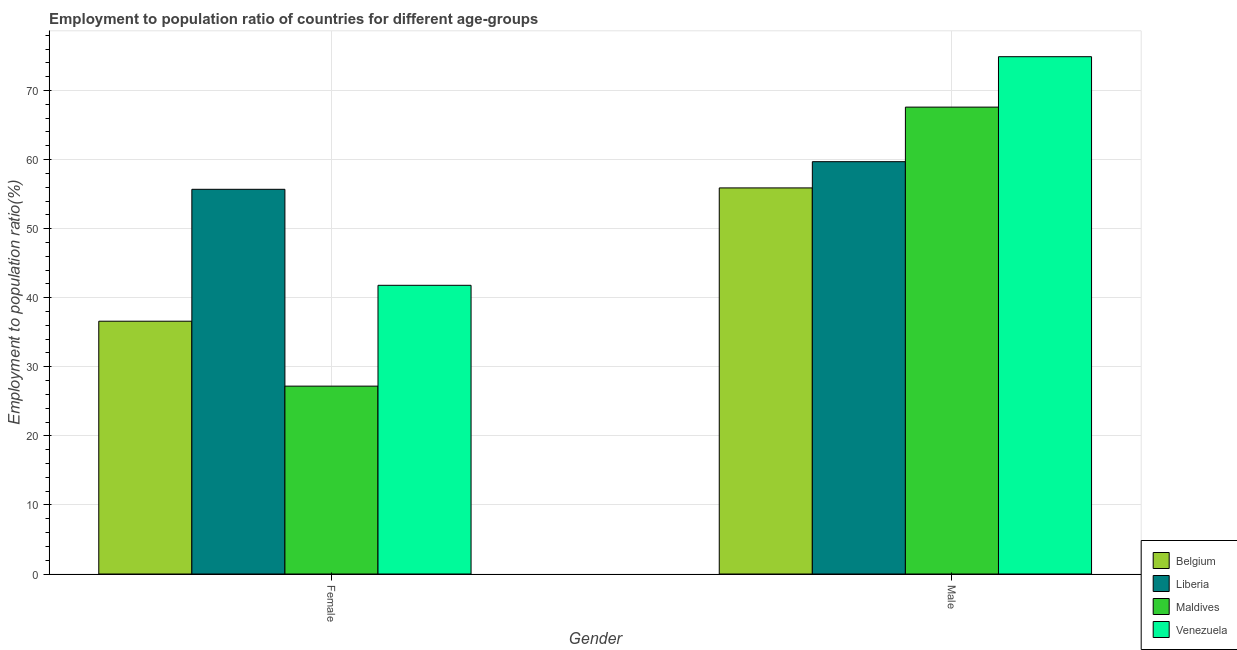How many different coloured bars are there?
Ensure brevity in your answer.  4. How many groups of bars are there?
Offer a terse response. 2. Are the number of bars per tick equal to the number of legend labels?
Provide a succinct answer. Yes. How many bars are there on the 2nd tick from the left?
Keep it short and to the point. 4. What is the label of the 2nd group of bars from the left?
Give a very brief answer. Male. What is the employment to population ratio(female) in Liberia?
Your answer should be very brief. 55.7. Across all countries, what is the maximum employment to population ratio(male)?
Offer a terse response. 74.9. Across all countries, what is the minimum employment to population ratio(male)?
Give a very brief answer. 55.9. In which country was the employment to population ratio(male) maximum?
Offer a very short reply. Venezuela. In which country was the employment to population ratio(female) minimum?
Offer a very short reply. Maldives. What is the total employment to population ratio(female) in the graph?
Provide a short and direct response. 161.3. What is the difference between the employment to population ratio(female) in Liberia and that in Belgium?
Keep it short and to the point. 19.1. What is the difference between the employment to population ratio(male) in Maldives and the employment to population ratio(female) in Liberia?
Make the answer very short. 11.9. What is the average employment to population ratio(female) per country?
Ensure brevity in your answer.  40.32. What is the difference between the employment to population ratio(female) and employment to population ratio(male) in Maldives?
Provide a short and direct response. -40.4. In how many countries, is the employment to population ratio(male) greater than 20 %?
Give a very brief answer. 4. What is the ratio of the employment to population ratio(male) in Liberia to that in Belgium?
Your response must be concise. 1.07. What does the 1st bar from the left in Female represents?
Your answer should be compact. Belgium. What does the 2nd bar from the right in Male represents?
Give a very brief answer. Maldives. How many countries are there in the graph?
Your answer should be compact. 4. What is the difference between two consecutive major ticks on the Y-axis?
Your response must be concise. 10. Are the values on the major ticks of Y-axis written in scientific E-notation?
Offer a terse response. No. Does the graph contain grids?
Offer a very short reply. Yes. How many legend labels are there?
Provide a succinct answer. 4. How are the legend labels stacked?
Keep it short and to the point. Vertical. What is the title of the graph?
Provide a succinct answer. Employment to population ratio of countries for different age-groups. What is the label or title of the X-axis?
Provide a short and direct response. Gender. What is the Employment to population ratio(%) in Belgium in Female?
Your response must be concise. 36.6. What is the Employment to population ratio(%) of Liberia in Female?
Keep it short and to the point. 55.7. What is the Employment to population ratio(%) of Maldives in Female?
Provide a succinct answer. 27.2. What is the Employment to population ratio(%) of Venezuela in Female?
Keep it short and to the point. 41.8. What is the Employment to population ratio(%) of Belgium in Male?
Offer a very short reply. 55.9. What is the Employment to population ratio(%) in Liberia in Male?
Your response must be concise. 59.7. What is the Employment to population ratio(%) of Maldives in Male?
Offer a terse response. 67.6. What is the Employment to population ratio(%) in Venezuela in Male?
Give a very brief answer. 74.9. Across all Gender, what is the maximum Employment to population ratio(%) of Belgium?
Give a very brief answer. 55.9. Across all Gender, what is the maximum Employment to population ratio(%) in Liberia?
Your answer should be very brief. 59.7. Across all Gender, what is the maximum Employment to population ratio(%) in Maldives?
Ensure brevity in your answer.  67.6. Across all Gender, what is the maximum Employment to population ratio(%) in Venezuela?
Provide a short and direct response. 74.9. Across all Gender, what is the minimum Employment to population ratio(%) in Belgium?
Offer a terse response. 36.6. Across all Gender, what is the minimum Employment to population ratio(%) of Liberia?
Offer a very short reply. 55.7. Across all Gender, what is the minimum Employment to population ratio(%) of Maldives?
Provide a succinct answer. 27.2. Across all Gender, what is the minimum Employment to population ratio(%) of Venezuela?
Your answer should be very brief. 41.8. What is the total Employment to population ratio(%) in Belgium in the graph?
Give a very brief answer. 92.5. What is the total Employment to population ratio(%) of Liberia in the graph?
Give a very brief answer. 115.4. What is the total Employment to population ratio(%) of Maldives in the graph?
Keep it short and to the point. 94.8. What is the total Employment to population ratio(%) of Venezuela in the graph?
Offer a terse response. 116.7. What is the difference between the Employment to population ratio(%) in Belgium in Female and that in Male?
Your response must be concise. -19.3. What is the difference between the Employment to population ratio(%) in Liberia in Female and that in Male?
Your answer should be compact. -4. What is the difference between the Employment to population ratio(%) of Maldives in Female and that in Male?
Offer a terse response. -40.4. What is the difference between the Employment to population ratio(%) of Venezuela in Female and that in Male?
Keep it short and to the point. -33.1. What is the difference between the Employment to population ratio(%) in Belgium in Female and the Employment to population ratio(%) in Liberia in Male?
Your response must be concise. -23.1. What is the difference between the Employment to population ratio(%) in Belgium in Female and the Employment to population ratio(%) in Maldives in Male?
Give a very brief answer. -31. What is the difference between the Employment to population ratio(%) in Belgium in Female and the Employment to population ratio(%) in Venezuela in Male?
Keep it short and to the point. -38.3. What is the difference between the Employment to population ratio(%) of Liberia in Female and the Employment to population ratio(%) of Venezuela in Male?
Your response must be concise. -19.2. What is the difference between the Employment to population ratio(%) of Maldives in Female and the Employment to population ratio(%) of Venezuela in Male?
Provide a short and direct response. -47.7. What is the average Employment to population ratio(%) in Belgium per Gender?
Provide a short and direct response. 46.25. What is the average Employment to population ratio(%) of Liberia per Gender?
Offer a terse response. 57.7. What is the average Employment to population ratio(%) in Maldives per Gender?
Offer a very short reply. 47.4. What is the average Employment to population ratio(%) in Venezuela per Gender?
Keep it short and to the point. 58.35. What is the difference between the Employment to population ratio(%) in Belgium and Employment to population ratio(%) in Liberia in Female?
Your answer should be very brief. -19.1. What is the difference between the Employment to population ratio(%) of Liberia and Employment to population ratio(%) of Maldives in Female?
Offer a terse response. 28.5. What is the difference between the Employment to population ratio(%) in Maldives and Employment to population ratio(%) in Venezuela in Female?
Offer a terse response. -14.6. What is the difference between the Employment to population ratio(%) in Belgium and Employment to population ratio(%) in Liberia in Male?
Your answer should be very brief. -3.8. What is the difference between the Employment to population ratio(%) of Belgium and Employment to population ratio(%) of Maldives in Male?
Your answer should be very brief. -11.7. What is the difference between the Employment to population ratio(%) in Belgium and Employment to population ratio(%) in Venezuela in Male?
Give a very brief answer. -19. What is the difference between the Employment to population ratio(%) of Liberia and Employment to population ratio(%) of Venezuela in Male?
Give a very brief answer. -15.2. What is the difference between the Employment to population ratio(%) of Maldives and Employment to population ratio(%) of Venezuela in Male?
Keep it short and to the point. -7.3. What is the ratio of the Employment to population ratio(%) of Belgium in Female to that in Male?
Offer a terse response. 0.65. What is the ratio of the Employment to population ratio(%) of Liberia in Female to that in Male?
Offer a terse response. 0.93. What is the ratio of the Employment to population ratio(%) of Maldives in Female to that in Male?
Offer a very short reply. 0.4. What is the ratio of the Employment to population ratio(%) of Venezuela in Female to that in Male?
Offer a very short reply. 0.56. What is the difference between the highest and the second highest Employment to population ratio(%) in Belgium?
Your response must be concise. 19.3. What is the difference between the highest and the second highest Employment to population ratio(%) of Maldives?
Keep it short and to the point. 40.4. What is the difference between the highest and the second highest Employment to population ratio(%) in Venezuela?
Offer a terse response. 33.1. What is the difference between the highest and the lowest Employment to population ratio(%) of Belgium?
Keep it short and to the point. 19.3. What is the difference between the highest and the lowest Employment to population ratio(%) of Maldives?
Make the answer very short. 40.4. What is the difference between the highest and the lowest Employment to population ratio(%) in Venezuela?
Your answer should be very brief. 33.1. 